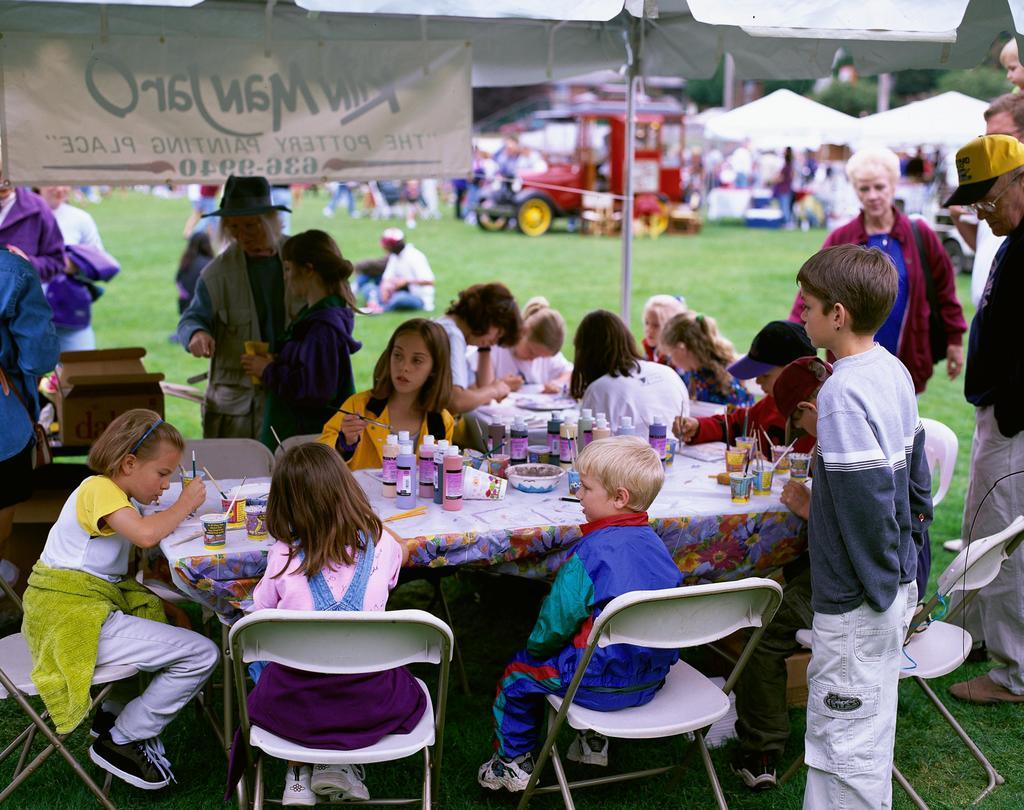Who is present in the image? There are children in the image. What are the children doing in the image? The children are sitting around a table and painting. What is the reason behind the children's digestion process in the image? There is no information about the children's digestion process in the image, as it focuses on their painting activity. 